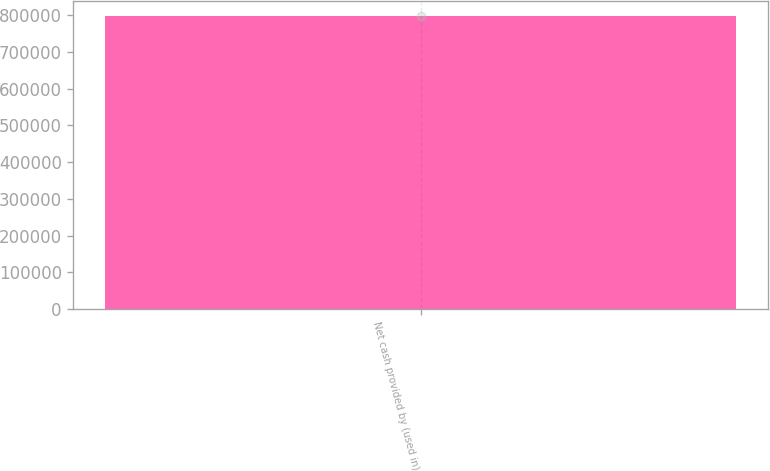<chart> <loc_0><loc_0><loc_500><loc_500><bar_chart><fcel>Net cash provided by (used in)<nl><fcel>798305<nl></chart> 